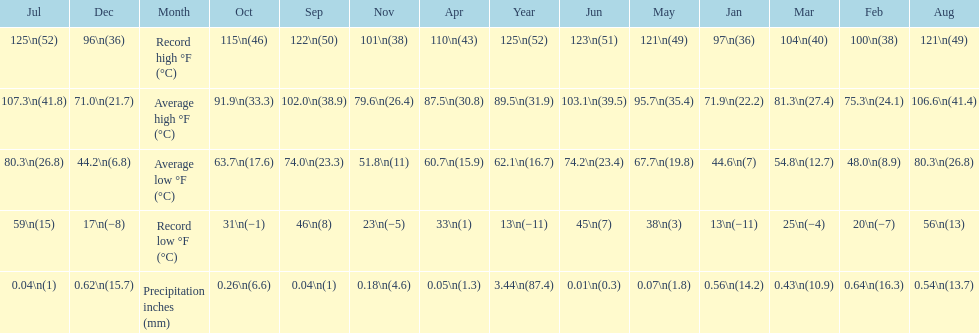How long was the monthly average temperature 100 degrees or more? 4 months. 